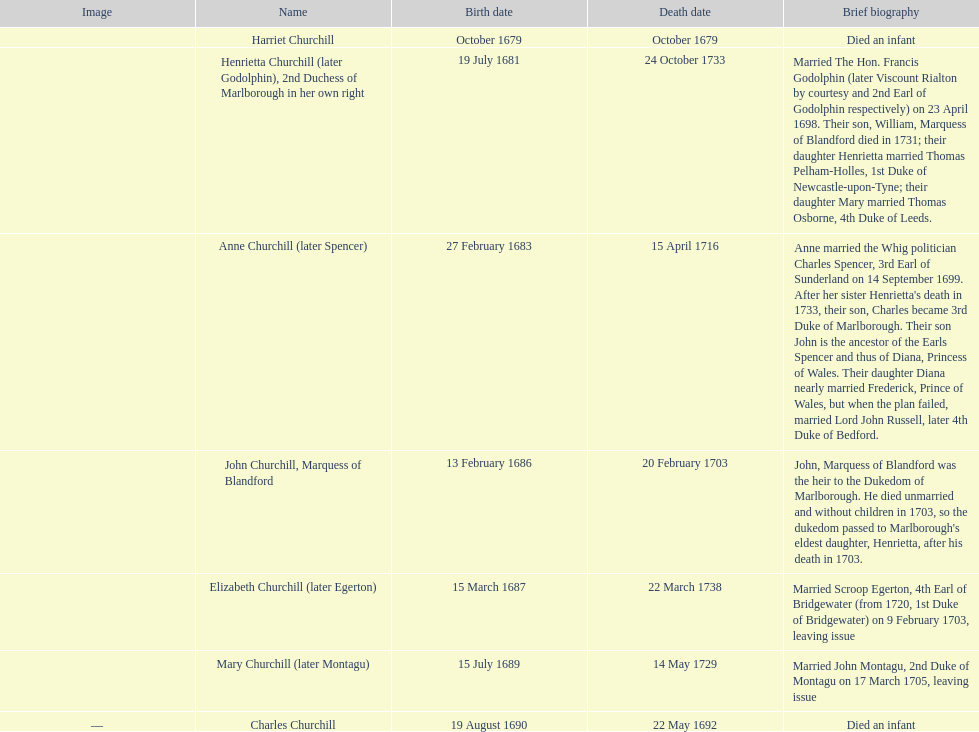Which child was born after elizabeth churchill? Mary Churchill. 